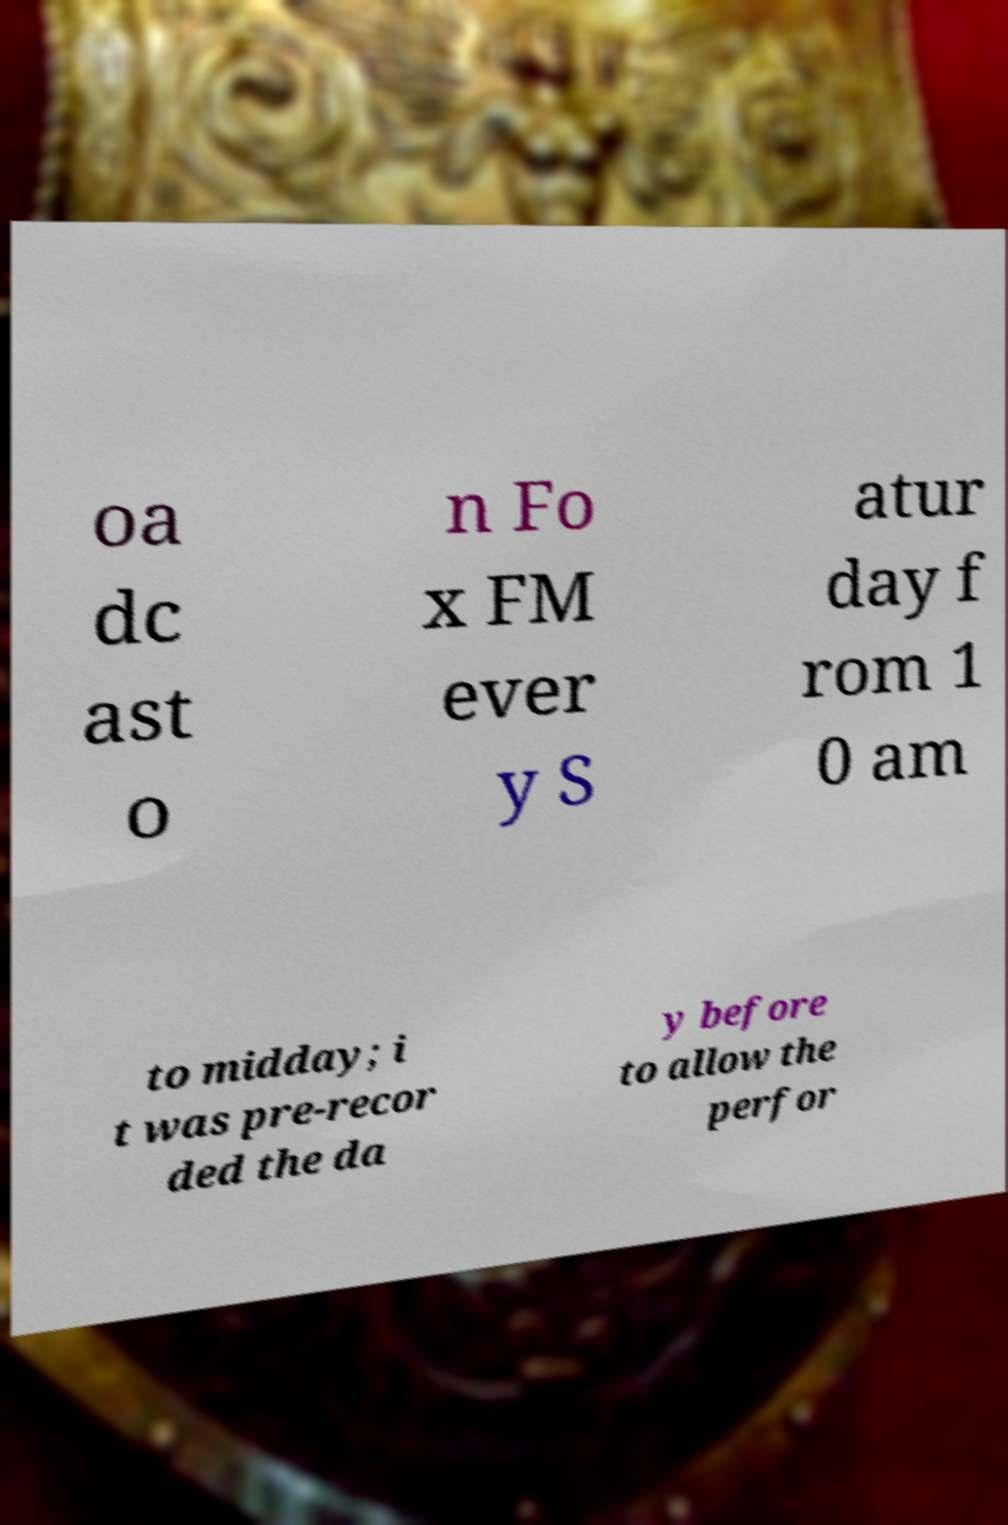What messages or text are displayed in this image? I need them in a readable, typed format. oa dc ast o n Fo x FM ever y S atur day f rom 1 0 am to midday; i t was pre-recor ded the da y before to allow the perfor 